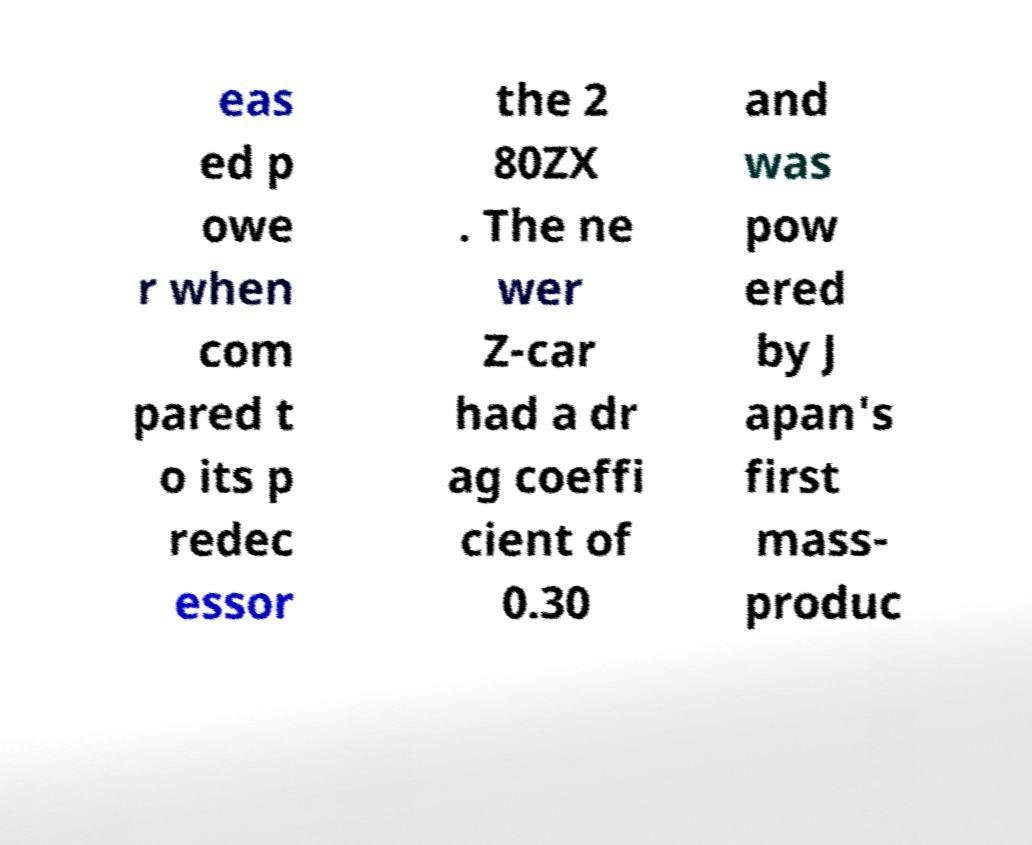There's text embedded in this image that I need extracted. Can you transcribe it verbatim? eas ed p owe r when com pared t o its p redec essor the 2 80ZX . The ne wer Z-car had a dr ag coeffi cient of 0.30 and was pow ered by J apan's first mass- produc 